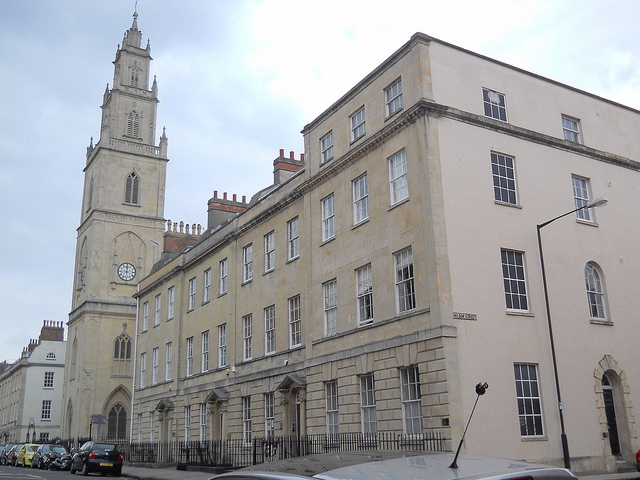Imagine a fantasy creature living in this building. Describe it. In this grand, historic building lives a mythical creature named Wyndra, the Guardian of Time. Wyndra is a dragon-like entity with shimmering scales that reflect the colors of the sky. Its wings span the width of the building, and its eyes hold the secrets of centuries. Wyndra is said to be the protector of this ancient structure, ensuring that time flows uninterrupted within its walls. Citizens speak of hearing a gentle hum at night, believed to be Wyndra's lullaby keeping the building and its inhabitants safe. What kind of tasks does Wyndra perform? Wyndra performs several important tasks. Primarily, it ensures the integrity of the building by using its powers to restore any wear and tear instantly. It also guards a hidden library within the walls, filled with ancient texts and forgotten knowledge. During full moons, Wyndra takes flight around the city, casting protective spells to ward off any misfortune. Occasionally, it communicates with the building’s inhabitants through dreams, offering guidance and wisdom. Describe one of Wyndra's most memorable encounters. One of Wyndra's most memorable encounters was with a young historian named Evelyn. Evelyn was researching the building's hidden library but faced numerous challenges deciphering old manuscripts. One night, Wyndra appeared in her dreams and guided her to a secret compartment in the library. Inside, Evelyn found a manuscript detailing a powerful spell that revealed the true meaning of all texts. This encounter not only aided Evelyn in her research but also deepened the mystical bond between her and the ancient guardian. The manuscript's insights led to significant historical discoveries, shedding light on the city’s forgotten past. 